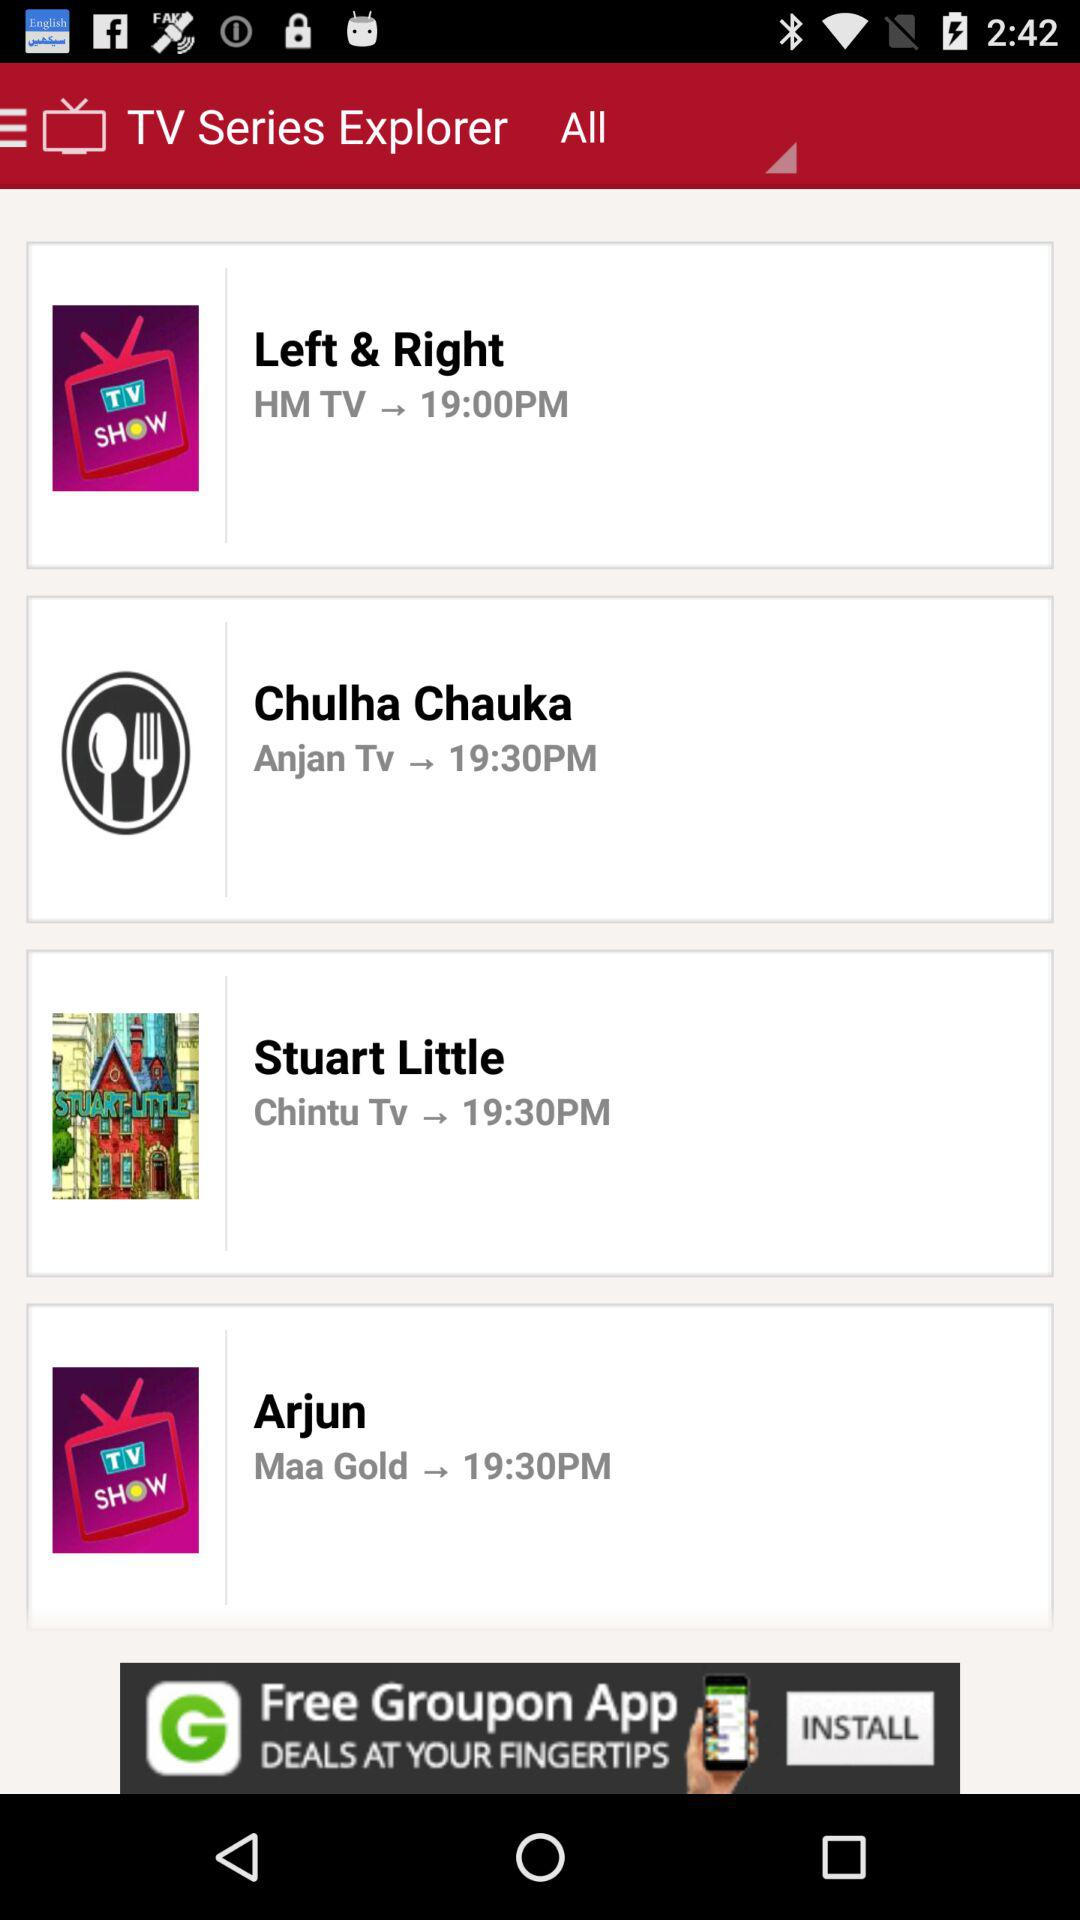What is the time of "Left & Right"? The time of "Left & Right" is 19:00. 